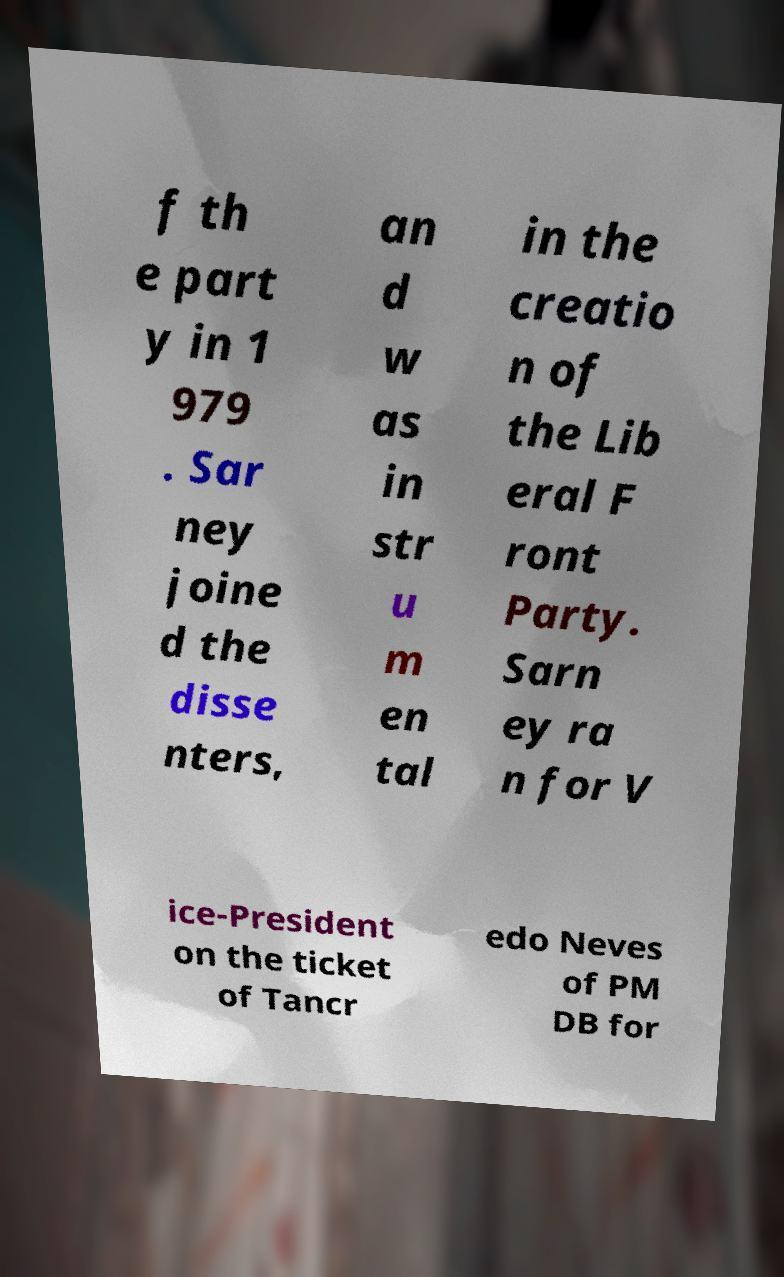Could you assist in decoding the text presented in this image and type it out clearly? f th e part y in 1 979 . Sar ney joine d the disse nters, an d w as in str u m en tal in the creatio n of the Lib eral F ront Party. Sarn ey ra n for V ice-President on the ticket of Tancr edo Neves of PM DB for 